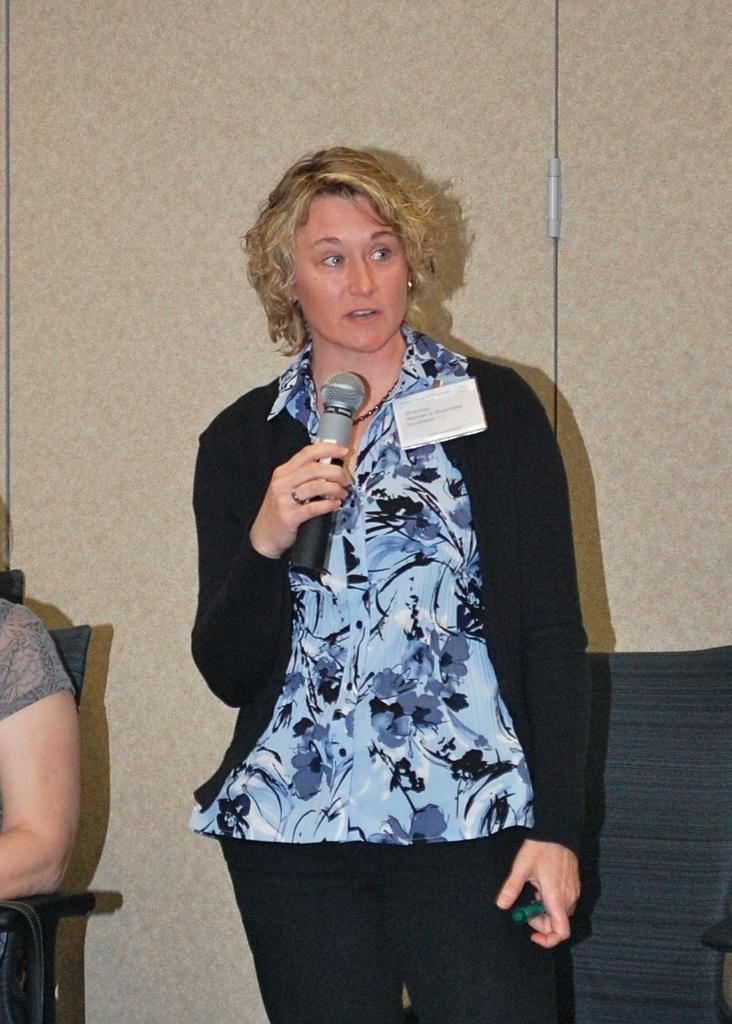Describe this image in one or two sentences. This picture show´s a woman standing and speaking with their hand and we see a woman seated on the chair 